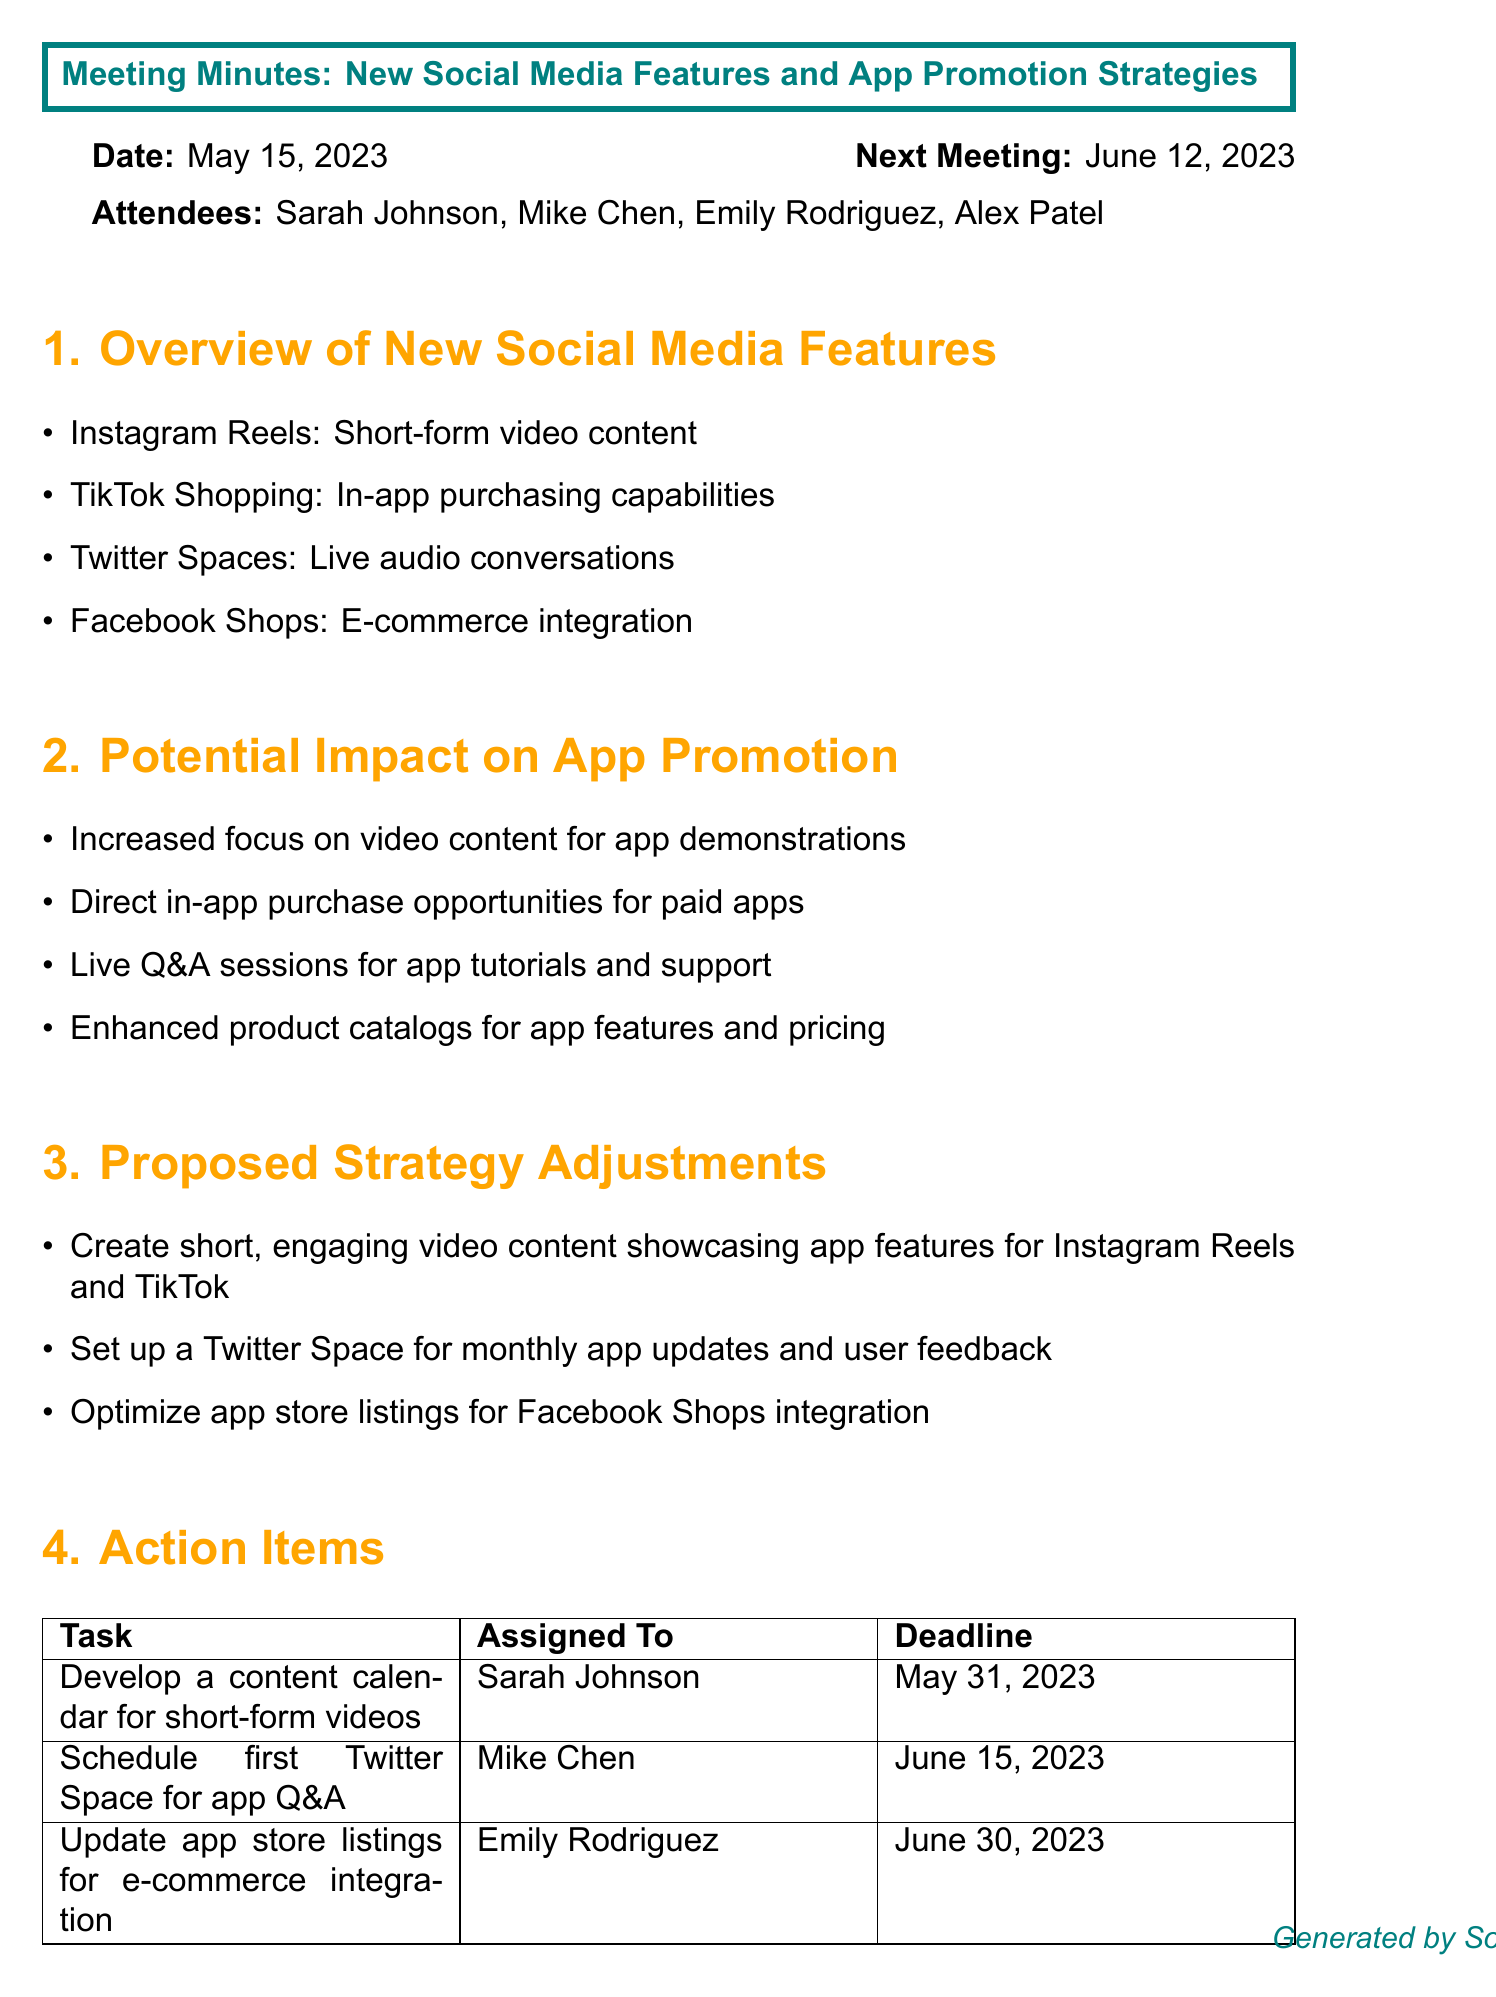What is the meeting title? The meeting title is mentioned at the start of the document.
Answer: New Social Media Features and App Promotion Strategies Who is the Social Media Manager? The attendee list specifies the role of each person present in the meeting.
Answer: Sarah Johnson What are the new social media features discussed? The section titled "Overview of New Social Media Features" lists the features.
Answer: Instagram Reels, TikTok Shopping, Twitter Spaces, Facebook Shops What is one proposed strategy adjustment? The section titled "Proposed Strategy Adjustments" contains various strategic changes.
Answer: Create short, engaging video content showcasing app features What is the deadline for the content calendar task? Each action item has a designated deadline noted in the "Action Items" section.
Answer: May 31, 2023 Which attendee is responsible for scheduling the Twitter Space? The action items list includes responsible individuals for each task.
Answer: Mike Chen How many agenda items were discussed in total? By counting the sections listed in the document, we can determine the number of agenda items.
Answer: Four What is the date of the next meeting? The next meeting date is provided at the beginning of the document.
Answer: June 12, 2023 